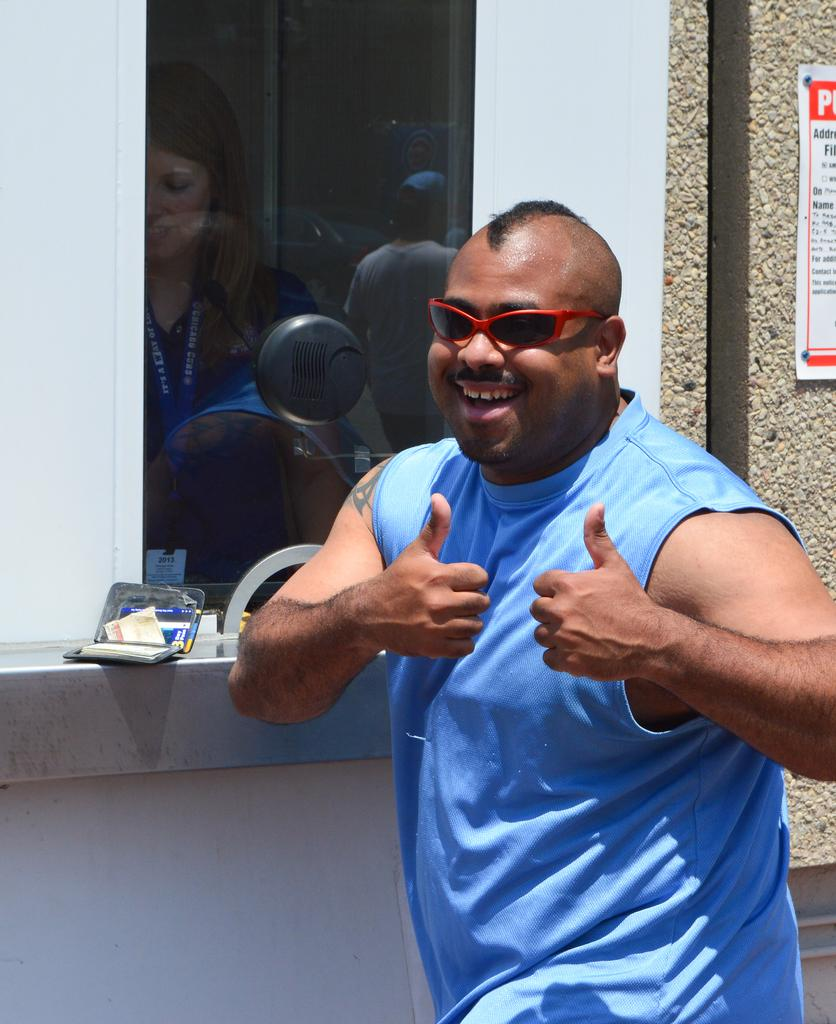Who is present in the image? There is a man in the image. What is the man wearing? The man is wearing a blue T-shirt and spectacles. What can be seen in the background of the image? There are people visible in the mirror reflection, and there is a poster on the wall beside the man. What type of pet is sitting on the man's shoulder in the image? There is no pet visible on the man's shoulder in the image. What kind of crown is the man wearing in the image? The man is not wearing a crown in the image; he is wearing spectacles. 